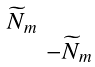Convert formula to latex. <formula><loc_0><loc_0><loc_500><loc_500>\begin{smallmatrix} \widetilde { N } _ { m } & \\ & - \widetilde { N } _ { m } \end{smallmatrix}</formula> 